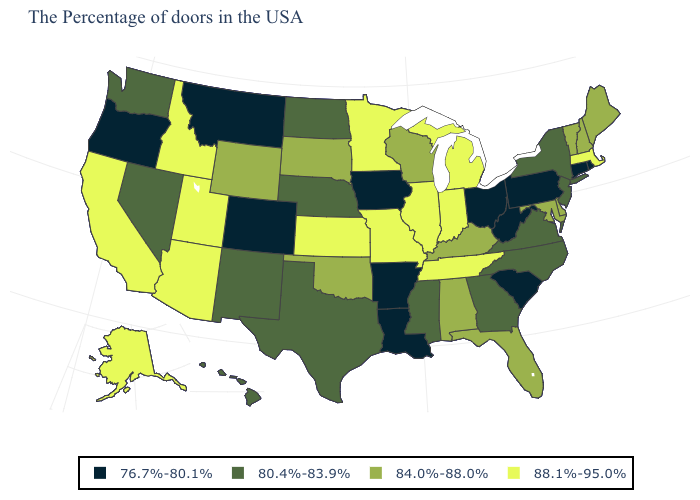Which states have the lowest value in the USA?
Write a very short answer. Rhode Island, Connecticut, Pennsylvania, South Carolina, West Virginia, Ohio, Louisiana, Arkansas, Iowa, Colorado, Montana, Oregon. Name the states that have a value in the range 76.7%-80.1%?
Concise answer only. Rhode Island, Connecticut, Pennsylvania, South Carolina, West Virginia, Ohio, Louisiana, Arkansas, Iowa, Colorado, Montana, Oregon. What is the value of Minnesota?
Answer briefly. 88.1%-95.0%. Among the states that border Washington , does Idaho have the lowest value?
Quick response, please. No. Does the map have missing data?
Keep it brief. No. What is the value of Virginia?
Give a very brief answer. 80.4%-83.9%. Name the states that have a value in the range 80.4%-83.9%?
Keep it brief. New York, New Jersey, Virginia, North Carolina, Georgia, Mississippi, Nebraska, Texas, North Dakota, New Mexico, Nevada, Washington, Hawaii. What is the value of New York?
Write a very short answer. 80.4%-83.9%. Name the states that have a value in the range 88.1%-95.0%?
Quick response, please. Massachusetts, Michigan, Indiana, Tennessee, Illinois, Missouri, Minnesota, Kansas, Utah, Arizona, Idaho, California, Alaska. Name the states that have a value in the range 88.1%-95.0%?
Give a very brief answer. Massachusetts, Michigan, Indiana, Tennessee, Illinois, Missouri, Minnesota, Kansas, Utah, Arizona, Idaho, California, Alaska. Among the states that border Tennessee , does Arkansas have the lowest value?
Short answer required. Yes. Does New Jersey have a lower value than Rhode Island?
Give a very brief answer. No. Does the first symbol in the legend represent the smallest category?
Short answer required. Yes. What is the value of Ohio?
Concise answer only. 76.7%-80.1%. 